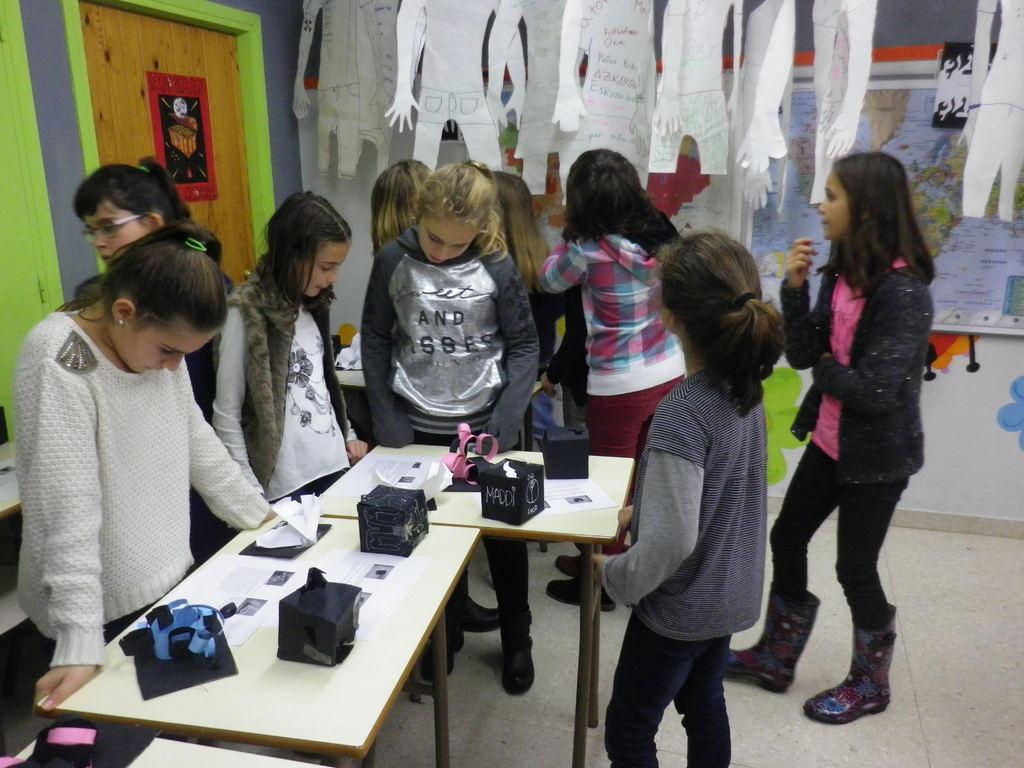Describe this image in one or two sentences. In this image there are group of girls who are looking into the paper which is on the table. On the table there are papers,paper boxes on it. At the top there are paper hangings. At the background there is wall,door and a map. 